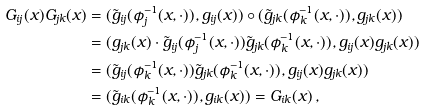<formula> <loc_0><loc_0><loc_500><loc_500>G _ { i j } ( x ) G _ { j k } ( x ) & = ( \tilde { g } _ { i j } ( \phi _ { j } ^ { - 1 } ( x , \cdot ) ) , g _ { i j } ( x ) ) \circ ( \tilde { g } _ { j k } ( \phi _ { k } ^ { - 1 } ( x , \cdot ) ) , g _ { j k } ( x ) ) \\ & = ( g _ { j k } ( x ) \cdot \tilde { g } _ { i j } ( \phi _ { j } ^ { - 1 } ( x , \cdot ) ) \tilde { g } _ { j k } ( \phi _ { k } ^ { - 1 } ( x , \cdot ) ) , g _ { i j } ( x ) g _ { j k } ( x ) ) \\ & = ( \tilde { g } _ { i j } ( \phi _ { k } ^ { - 1 } ( x , \cdot ) ) \tilde { g } _ { j k } ( \phi _ { k } ^ { - 1 } ( x , \cdot ) ) , g _ { i j } ( x ) g _ { j k } ( x ) ) \\ & = ( \tilde { g } _ { i k } ( \phi _ { k } ^ { - 1 } ( x , \cdot ) ) , g _ { i k } ( x ) ) = G _ { i k } ( x ) \, ,</formula> 